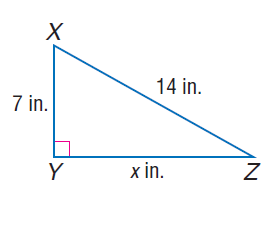Answer the mathemtical geometry problem and directly provide the correct option letter.
Question: Find x.
Choices: A: 7 B: 7 \sqrt { 3 } C: 14 D: 7 \sqrt { 5 } B 